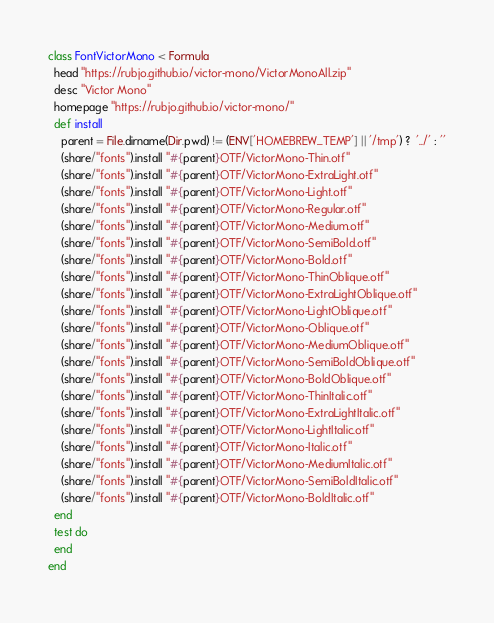Convert code to text. <code><loc_0><loc_0><loc_500><loc_500><_Ruby_>class FontVictorMono < Formula
  head "https://rubjo.github.io/victor-mono/VictorMonoAll.zip"
  desc "Victor Mono"
  homepage "https://rubjo.github.io/victor-mono/"
  def install
    parent = File.dirname(Dir.pwd) != (ENV['HOMEBREW_TEMP'] || '/tmp') ?  '../' : ''
    (share/"fonts").install "#{parent}OTF/VictorMono-Thin.otf"
    (share/"fonts").install "#{parent}OTF/VictorMono-ExtraLight.otf"
    (share/"fonts").install "#{parent}OTF/VictorMono-Light.otf"
    (share/"fonts").install "#{parent}OTF/VictorMono-Regular.otf"
    (share/"fonts").install "#{parent}OTF/VictorMono-Medium.otf"
    (share/"fonts").install "#{parent}OTF/VictorMono-SemiBold.otf"
    (share/"fonts").install "#{parent}OTF/VictorMono-Bold.otf"
    (share/"fonts").install "#{parent}OTF/VictorMono-ThinOblique.otf"
    (share/"fonts").install "#{parent}OTF/VictorMono-ExtraLightOblique.otf"
    (share/"fonts").install "#{parent}OTF/VictorMono-LightOblique.otf"
    (share/"fonts").install "#{parent}OTF/VictorMono-Oblique.otf"
    (share/"fonts").install "#{parent}OTF/VictorMono-MediumOblique.otf"
    (share/"fonts").install "#{parent}OTF/VictorMono-SemiBoldOblique.otf"
    (share/"fonts").install "#{parent}OTF/VictorMono-BoldOblique.otf"
    (share/"fonts").install "#{parent}OTF/VictorMono-ThinItalic.otf"
    (share/"fonts").install "#{parent}OTF/VictorMono-ExtraLightItalic.otf"
    (share/"fonts").install "#{parent}OTF/VictorMono-LightItalic.otf"
    (share/"fonts").install "#{parent}OTF/VictorMono-Italic.otf"
    (share/"fonts").install "#{parent}OTF/VictorMono-MediumItalic.otf"
    (share/"fonts").install "#{parent}OTF/VictorMono-SemiBoldItalic.otf"
    (share/"fonts").install "#{parent}OTF/VictorMono-BoldItalic.otf"
  end
  test do
  end
end
</code> 